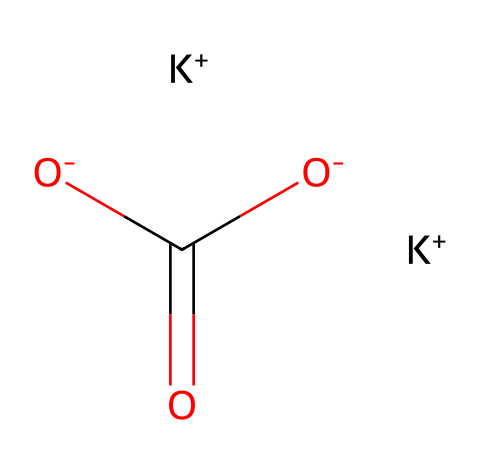What is the chemical name of this compound? The chemical name of the compound represented by the given SMILES is potassium carbonate. Potassium (K) is present with the carbonate group (CO3) acting as the base.
Answer: potassium carbonate How many potassium ions are present? By analyzing the SMILES, there are two "K+" signs, indicating two potassium ions are present in the compound.
Answer: two What type of compound is potassium carbonate? Potassium carbonate is classified as a salt derived from a strong base (potassium hydroxide) and a weak acid (carbonic acid). It possesses basic properties due to the presence of potassium cations and carbonate anions.
Answer: salt How many oxygen atoms are there in the structure? The carbonate group (CO3) contains three oxygen atoms, and there are no additional oxygen atoms in the structure, leading to a total of three oxygen atoms.
Answer: three What is the overall charge of potassium carbonate? The potassium ions (2 K+) each contribute a charge of +1, and the carbonate ion (CO3) has a charge of -2. This results in a net charge of 0, indicating that the compound is neutral.
Answer: zero Is potassium carbonate a strong or weak base? Potassium carbonate is considered a weak base because it does not completely dissociate in solution and its pH is mild compared to strong bases like sodium hydroxide.
Answer: weak 